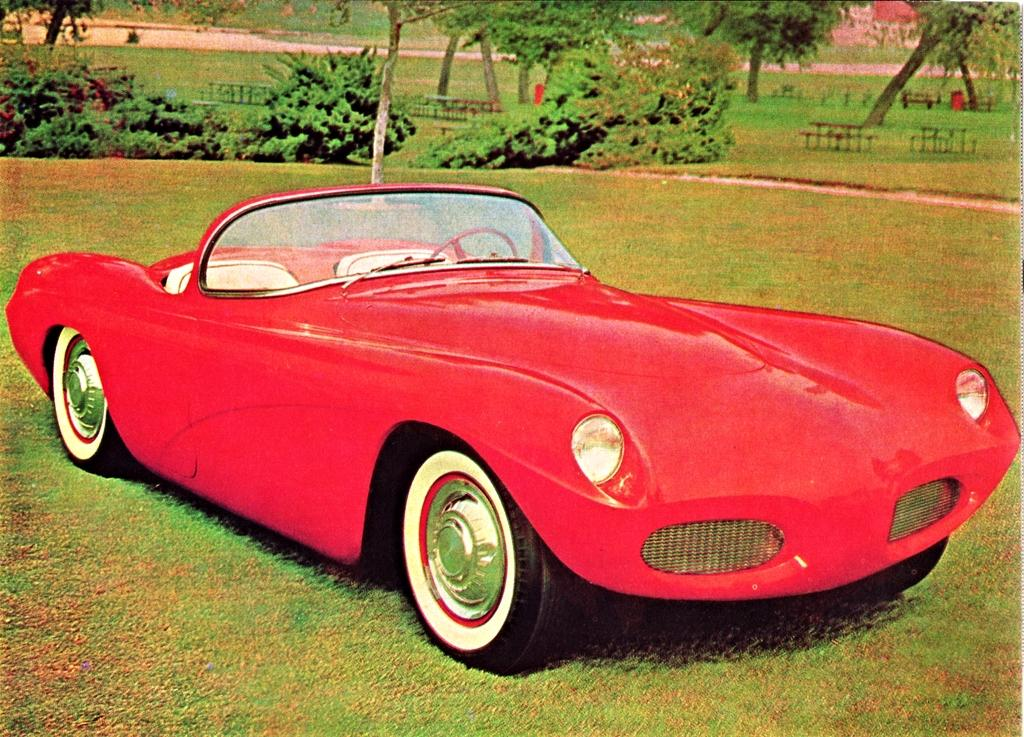What type of vehicle is in the image? There is a red car in the image. Where is the red car located? The red car is on the grassland. What type of natural environment is visible in the image? There are plants and trees visible in the image. What type of pin can be seen holding up the car in the image? There is no pin present in the image, and therefore no such object is holding up the car. What type of plant is growing in the hall in the image? There is no hall present in the image, and therefore no plants are growing in a hall. 